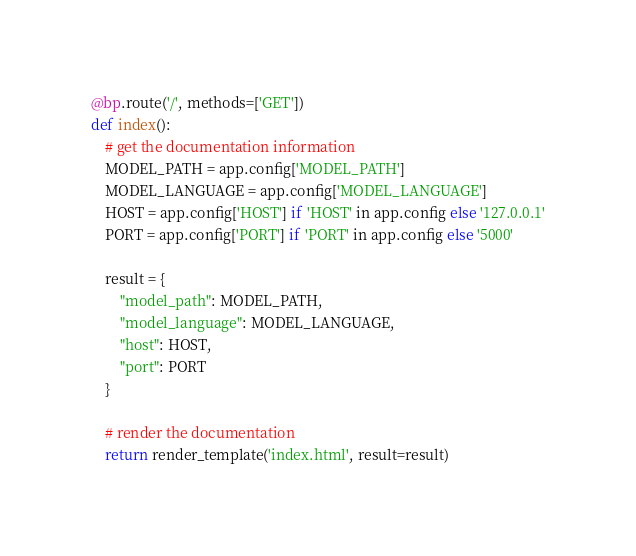Convert code to text. <code><loc_0><loc_0><loc_500><loc_500><_Python_>
@bp.route('/', methods=['GET'])
def index():
    # get the documentation information
    MODEL_PATH = app.config['MODEL_PATH']
    MODEL_LANGUAGE = app.config['MODEL_LANGUAGE']
    HOST = app.config['HOST'] if 'HOST' in app.config else '127.0.0.1'
    PORT = app.config['PORT'] if 'PORT' in app.config else '5000'

    result = {
        "model_path": MODEL_PATH,
        "model_language": MODEL_LANGUAGE,
        "host": HOST,
        "port": PORT
    }

    # render the documentation
    return render_template('index.html', result=result)</code> 